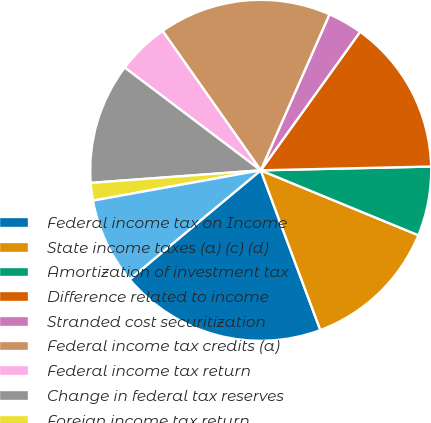<chart> <loc_0><loc_0><loc_500><loc_500><pie_chart><fcel>Federal income tax on Income<fcel>State income taxes (a) (c) (d)<fcel>Amortization of investment tax<fcel>Difference related to income<fcel>Stranded cost securitization<fcel>Federal income tax credits (a)<fcel>Federal income tax return<fcel>Change in federal tax reserves<fcel>Foreign income tax return<fcel>Domestic manufacturing<nl><fcel>19.64%<fcel>13.1%<fcel>6.57%<fcel>14.74%<fcel>3.3%<fcel>16.37%<fcel>4.94%<fcel>11.47%<fcel>1.67%<fcel>8.2%<nl></chart> 